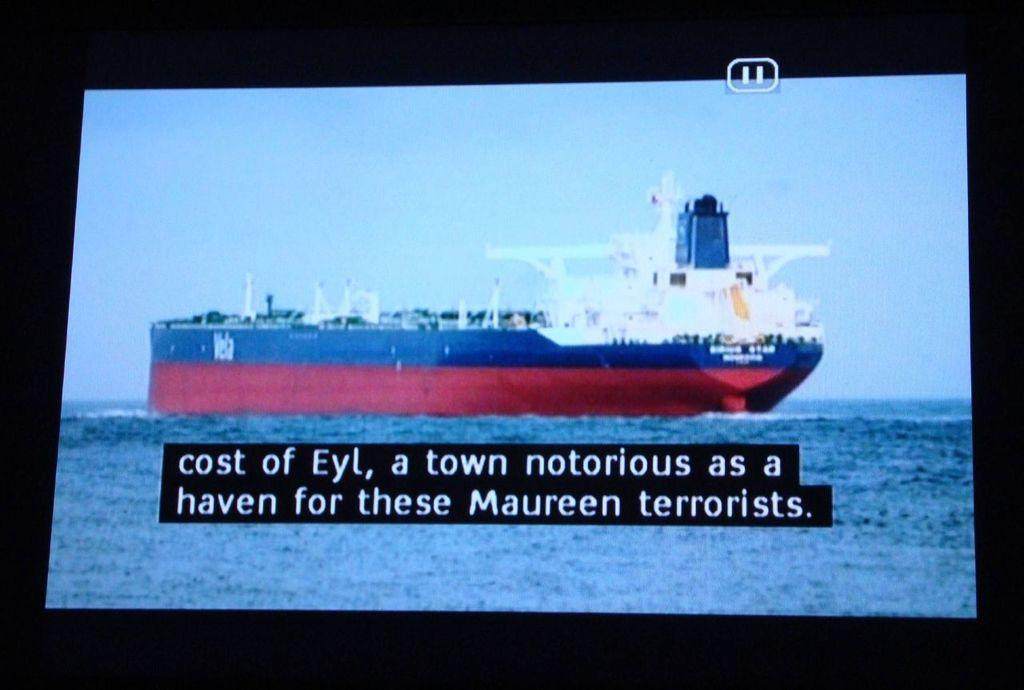Provide a one-sentence caption for the provided image. Shot of a large boat with closed captioning on a screen. 